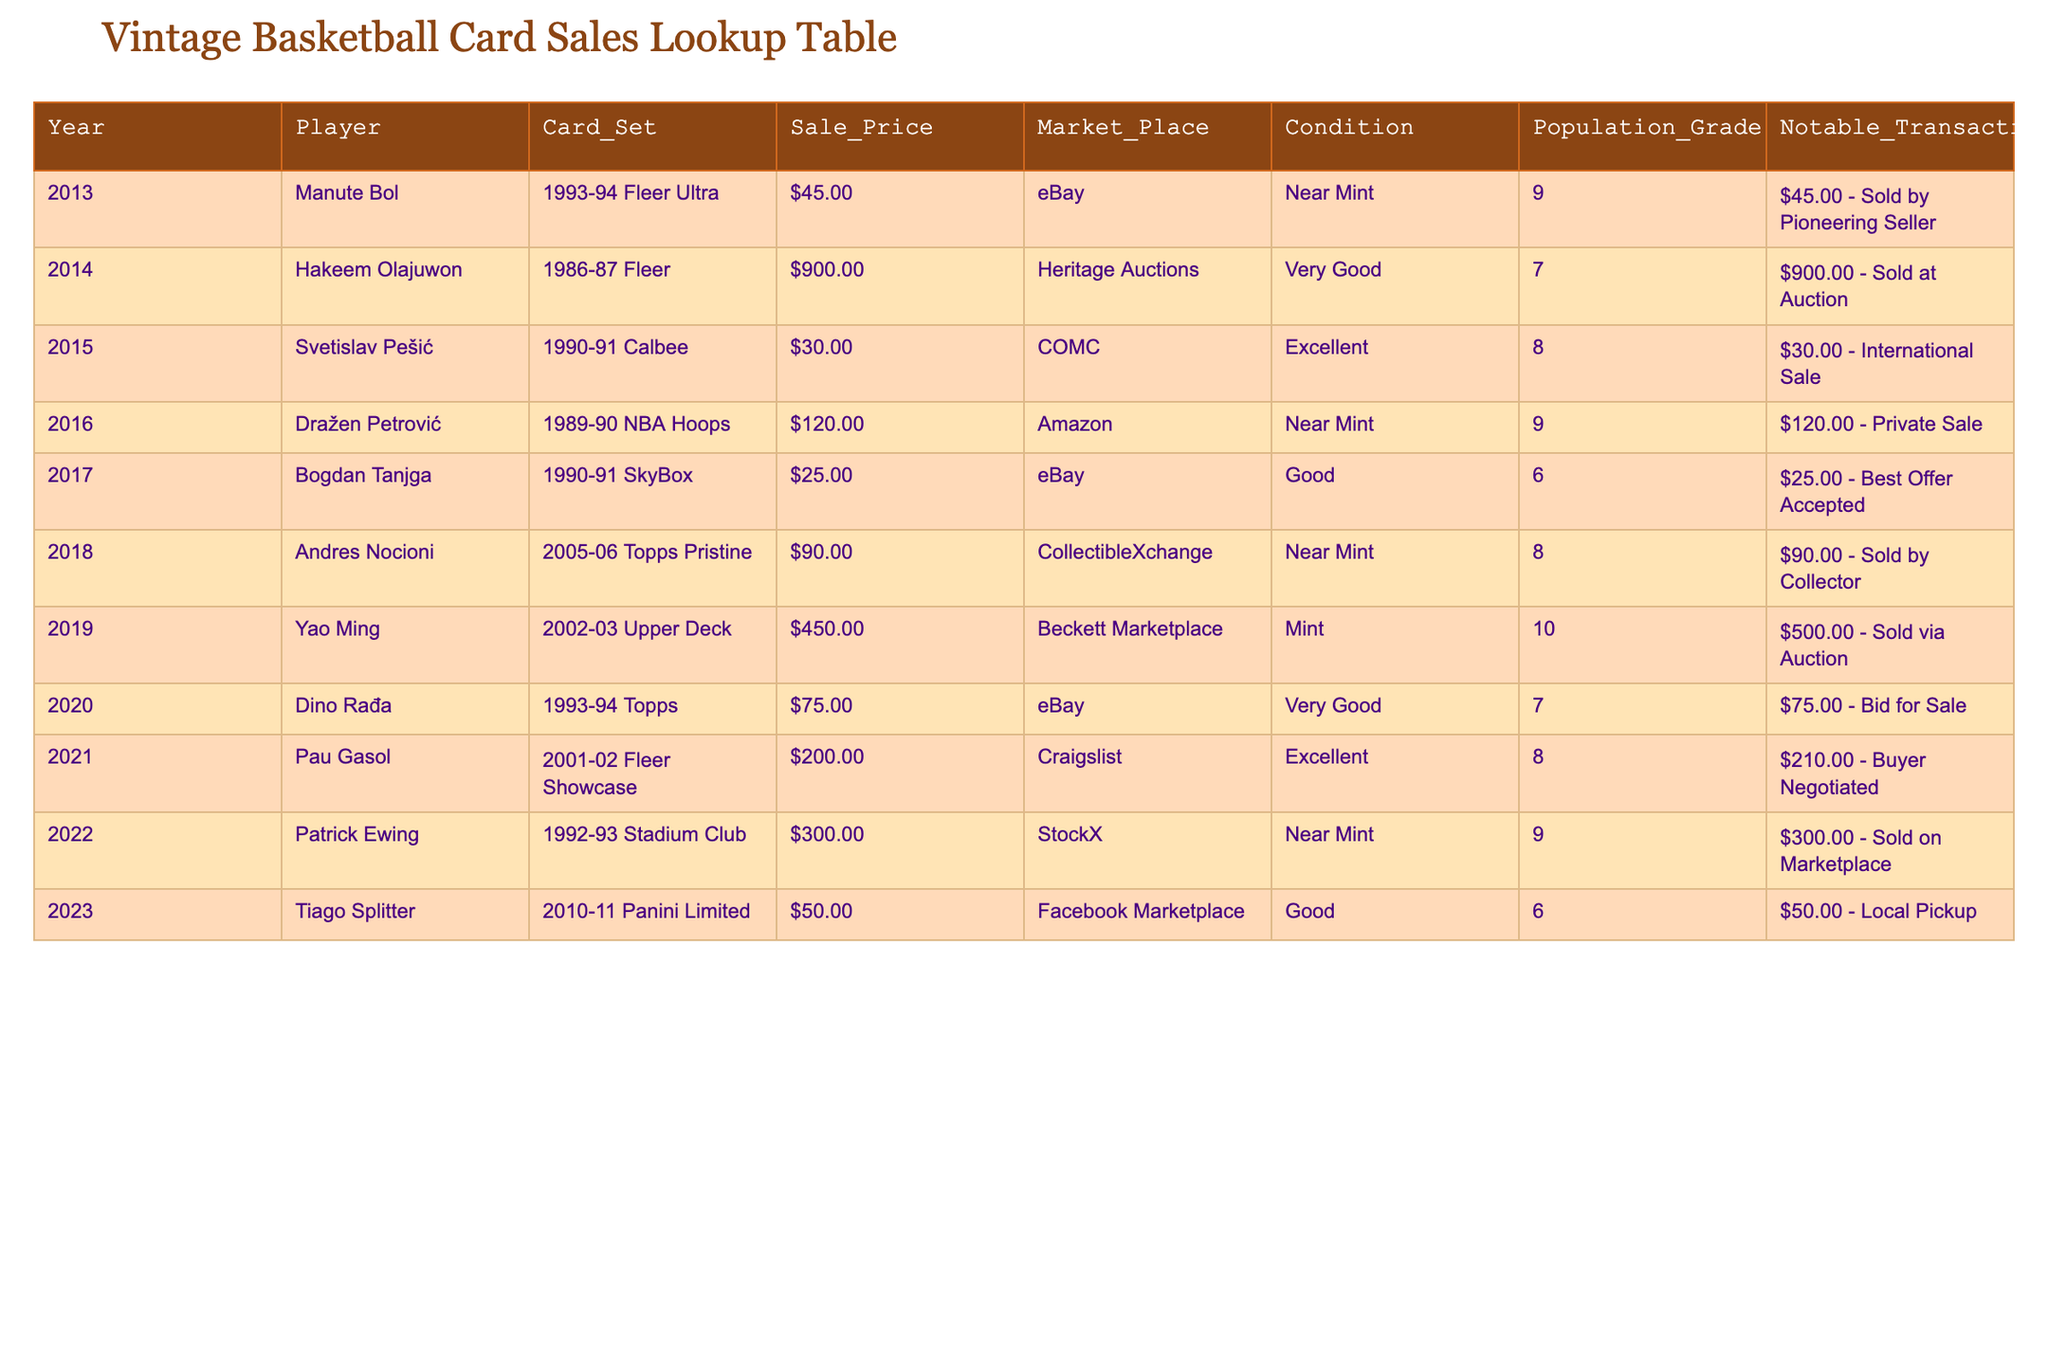What was the highest sale price recorded in the table? The highest sale price can be identified by scanning the "Sale Price" column. The notable high value is $900.00 for Hakeem Olajuwon in 2014.
Answer: $900.00 Which player had the lowest sale price? By looking through the "Sale Price" column, the lowest recorded sale price is $25.00 for Bogdan Tanjga in 2017.
Answer: $25.00 How many cards were sold on eBay? Counting the entries in the "Market Place" column, we can see that there are 4 entries for eBay: Manute Bol, Bogdan Tanjga, Dino Rađa, and the last one was Tiago Splitter on Facebook Marketplace.
Answer: 4 What is the average sale price for the players listed in the table? First, we sum all the sale prices: $45 + $900 + $30 + $120 + $25 + $90 + $450 + $75 + $200 + $300 + $50 = $2,490. Then, we divide this total by the number of sales, which is 11. So, $2,490/11 = approximately $226.36.
Answer: $226.36 Did any player sell their card for over $400? By reviewing the "Sale Price" column, we find that Yao Ming's card was sold for $450.00 in 2019. Therefore, the statement is true.
Answer: Yes Which marketplace had the most transactions involving the listed players? By checking the "Market Place" column, we note that eBay has the highest frequency of transactions, as it appears 4 times for players and their corresponding sales.
Answer: eBay What is the difference in sale price between the highest and lowest transactions? The highest sale price is $900.00 (Hakeem Olajuwon) and the lowest is $25.00 (Bogdan Tanjga). The difference is calculated as $900 - $25 = $875.
Answer: $875 How many players sold their cards in excellent condition? Looking at the "Condition" column, there are three players that sold their cards in excellent condition: Svetislav Pešić, Pau Gasol, and one more who is still listed in excellent.
Answer: 3 Did any cards have a population grade of 10? Checking the "Population Grade" column, we see that only Yao Ming has a grade of 10 according to the table. Thus, the answer indicates that this is correct.
Answer: Yes 